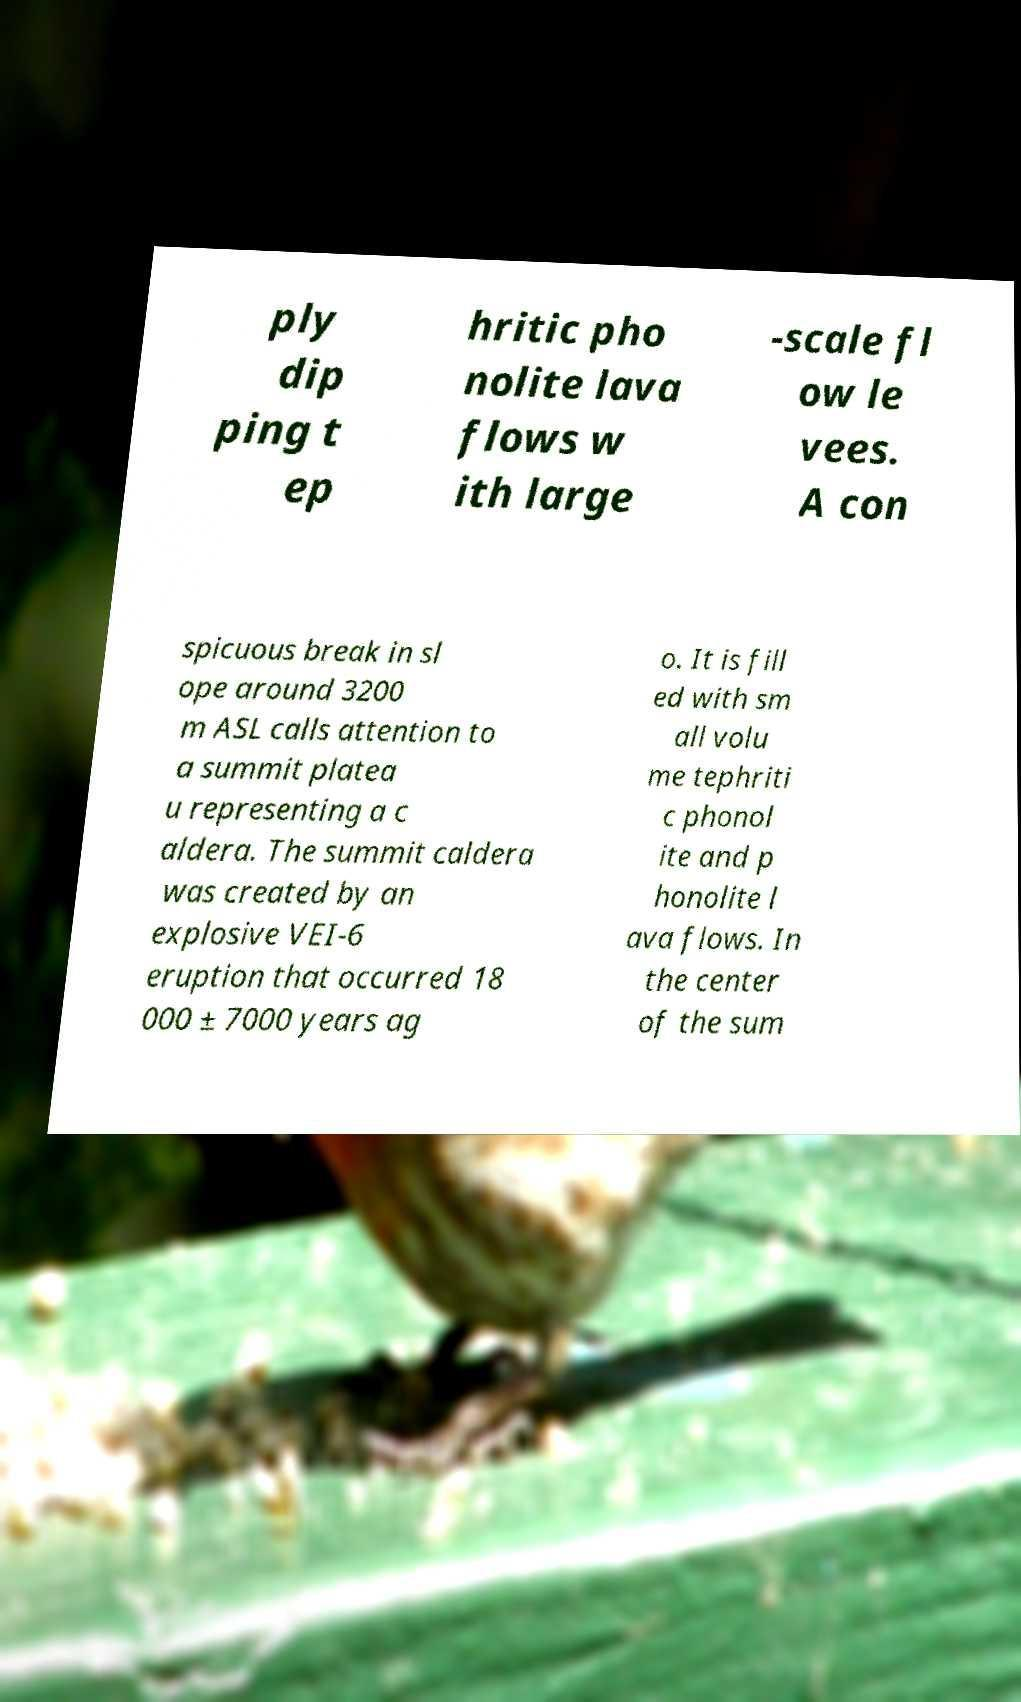What messages or text are displayed in this image? I need them in a readable, typed format. ply dip ping t ep hritic pho nolite lava flows w ith large -scale fl ow le vees. A con spicuous break in sl ope around 3200 m ASL calls attention to a summit platea u representing a c aldera. The summit caldera was created by an explosive VEI-6 eruption that occurred 18 000 ± 7000 years ag o. It is fill ed with sm all volu me tephriti c phonol ite and p honolite l ava flows. In the center of the sum 